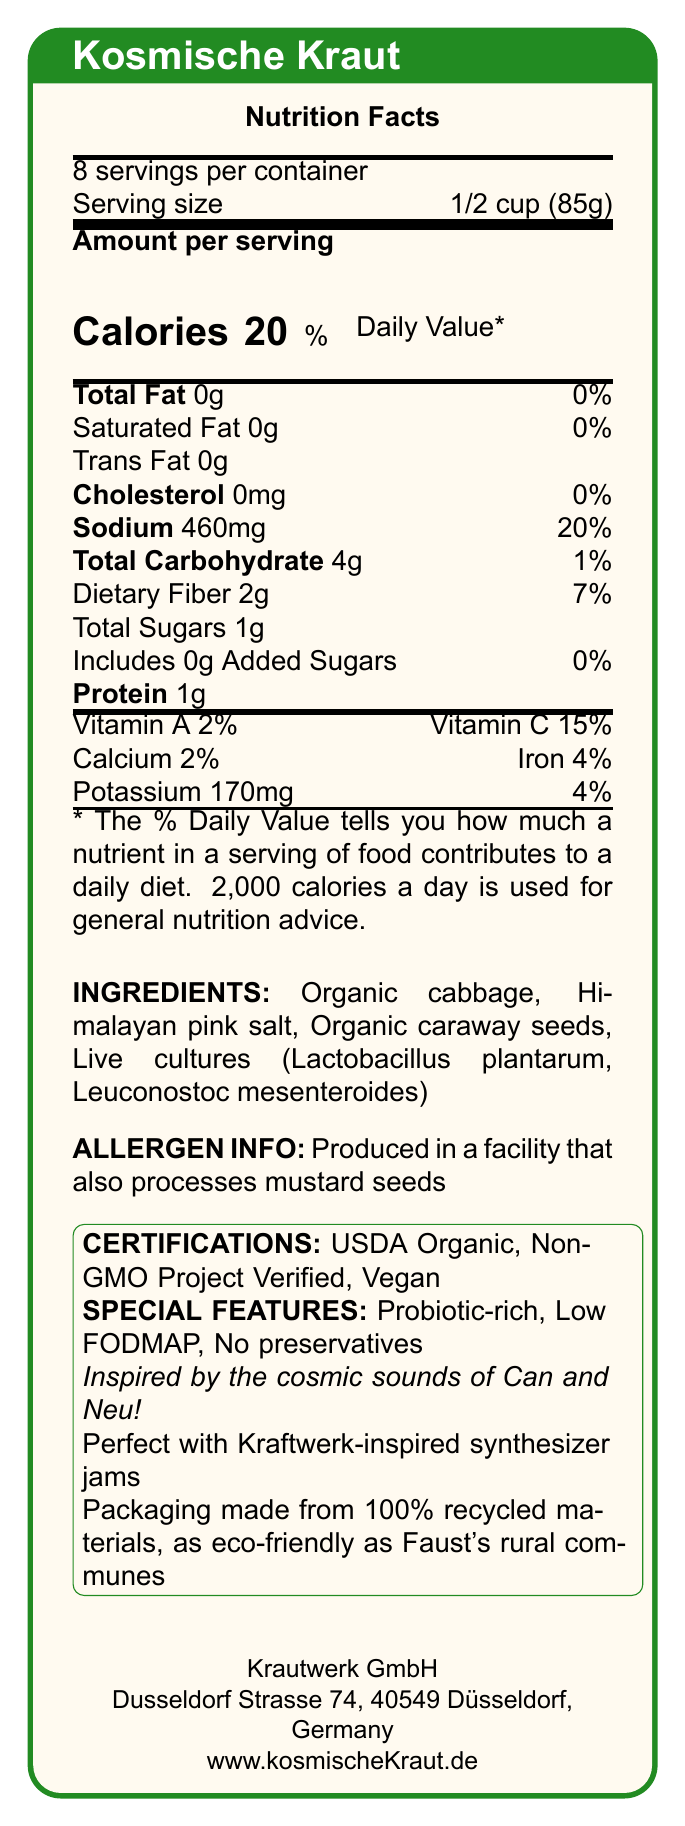what is the serving size for Kosmische Kraut? The document states that the serving size is 1/2 cup (85g).
Answer: 1/2 cup (85g) how many servings are in one container of Kosmische Kraut? According to the document, there are 8 servings per container.
Answer: 8 servings what is the sodium content per serving? The document lists the sodium content as 460mg per serving.
Answer: 460mg list three ingredients in Kosmische Kraut The ingredients listed in the document are Organic cabbage, Himalayan pink salt, Organic caraway seeds, and Live cultures (Lactobacillus plantarum, Leuconostoc mesenteroides).
Answer: Organic cabbage, Himalayan pink salt, Organic caraway seeds what percentage of daily value of Vitamin C does each serving provide? The document states that each serving provides 15% of the daily value of Vitamin C.
Answer: 15% what is the brand name of the sauerkraut? A. Krautrock Brand B. Cosmic Kraut C. Kosmische Kraut D. Krautwerk The document specifies the brand name as Kosmische Kraut.
Answer: C. Kosmische Kraut which certification is NOT listed for Kosmische Kraut? A. USDA Organic B. Non-GMO Project Verified C. Gluten-Free D. Vegan The document lists USDA Organic, Non-GMO Project Verified, and Vegan, but does not mention Gluten-Free.
Answer: C. Gluten-Free is this sauerkraut produced in a facility that processes mustard seeds? The allergen information states it is produced in a facility that also processes mustard seeds.
Answer: Yes describe the main idea of the document The document summarizes the key attributes of Kosmische Kraut, highlighting its nutritional benefits, special features like being probiotic-rich, and environmental credentials, all presented in a visually appealing manner.
Answer: The document provides comprehensive nutritional information, ingredients, certifications, and special features of a specialty German sauerkraut brand named Kosmische Kraut, along with manufacturer information and pairing suggestions. in which city is Krautwerk GmbH located? The manufacturer info section lists the address in Düsseldorf, Germany.
Answer: Düsseldorf what is the potassium content per serving? The document states that there is 170mg of potassium per serving.
Answer: 170mg which bands inspired the musical concept behind Kosmische Kraut? The document mentions that the sauerkraut is inspired by the cosmic sounds of Can and Neu!.
Answer: Can and Neu! can Kosmische Kraut be paired with rock music? The document specifically suggests pairing it with Kraftwerk-inspired synthesizer jams but does not provide information about pairing with rock music.
Answer: Not enough information does the packaging of Kosmische Kraut have eco-friendly features? The document notes that the packaging is made from 100% recycled materials, making it eco-friendly.
Answer: Yes how much calcium is provided per serving? The document lists the calcium content as 2% per serving.
Answer: 2% what is the total carbohydrate content per serving? According to the document, the total carbohydrate content per serving is 4g.
Answer: 4g 